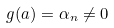Convert formula to latex. <formula><loc_0><loc_0><loc_500><loc_500>g ( a ) = \alpha _ { n } \neq 0</formula> 